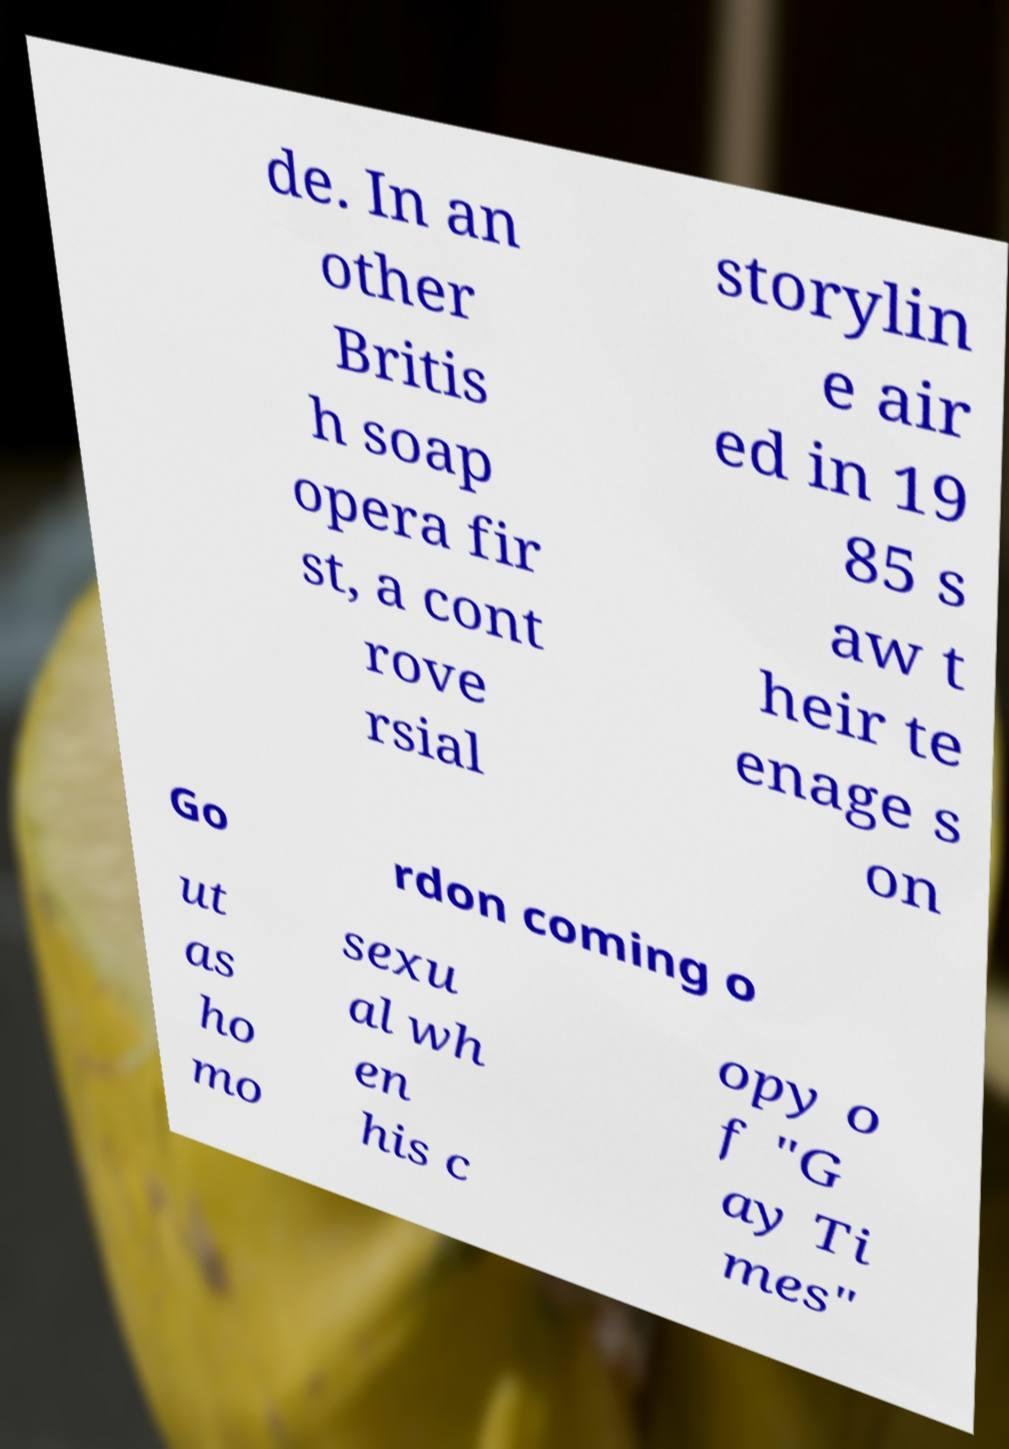There's text embedded in this image that I need extracted. Can you transcribe it verbatim? de. In an other Britis h soap opera fir st, a cont rove rsial storylin e air ed in 19 85 s aw t heir te enage s on Go rdon coming o ut as ho mo sexu al wh en his c opy o f "G ay Ti mes" 